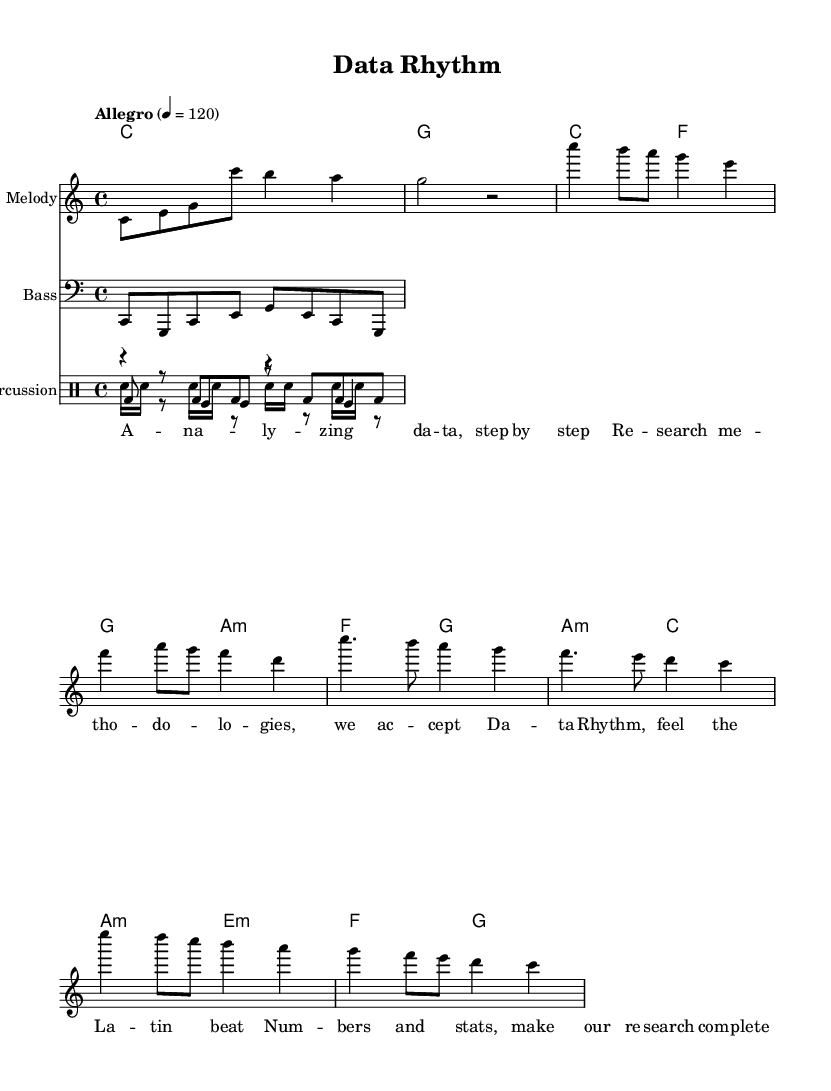What is the key signature of this music? The key signature is C major, which has no sharps or flats.
Answer: C major What is the time signature? The time signature shows that there are four beats in each measure, as indicated by the 4/4 notation.
Answer: 4/4 What is the tempo marking of the piece? The tempo marking indicates a speed of 120 beats per minute, denoted as "Allegro" and shown on the first line of the header.
Answer: Allegro 4 = 120 How many measures compose the chorus section? Counting the measures in the chorus section, there are four measures that can be identified between the marker for the chorus.
Answer: 4 What type of drum pattern is used for the congas? The congas section features a bass drum pattern indicated by the notation used in the drummode, specifically featuring a combination of bass and rests.
Answer: Bass drum pattern Describe the overall form of this piece. The piece is structured into distinct sections: an intro, a verse, a chorus, and a bridge, each serving different functions in the composition.
Answer: Intro, Verse, Chorus, Bridge What is the theme expressed in the lyrics? The lyrics depict an analytical approach to data and research methodologies, emphasized through a rhythmic and catchy Latin style.
Answer: Data analysis and research methodologies 